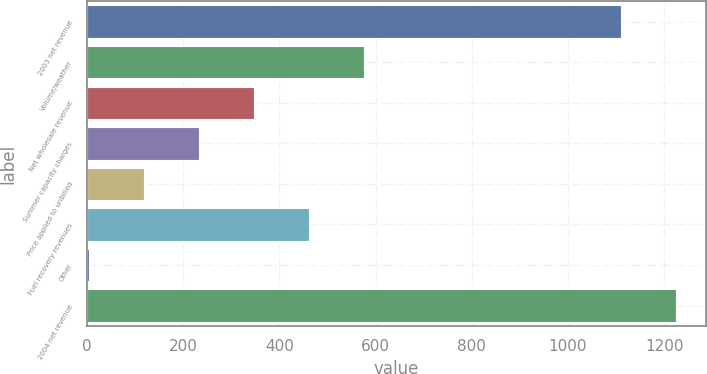Convert chart. <chart><loc_0><loc_0><loc_500><loc_500><bar_chart><fcel>2003 net revenue<fcel>Volume/weather<fcel>Net wholesale revenue<fcel>Summer capacity charges<fcel>Price applied to unbilled<fcel>Fuel recovery revenues<fcel>Other<fcel>2004 net revenue<nl><fcel>1110.1<fcel>576.85<fcel>347.67<fcel>233.08<fcel>118.49<fcel>462.26<fcel>3.9<fcel>1224.69<nl></chart> 